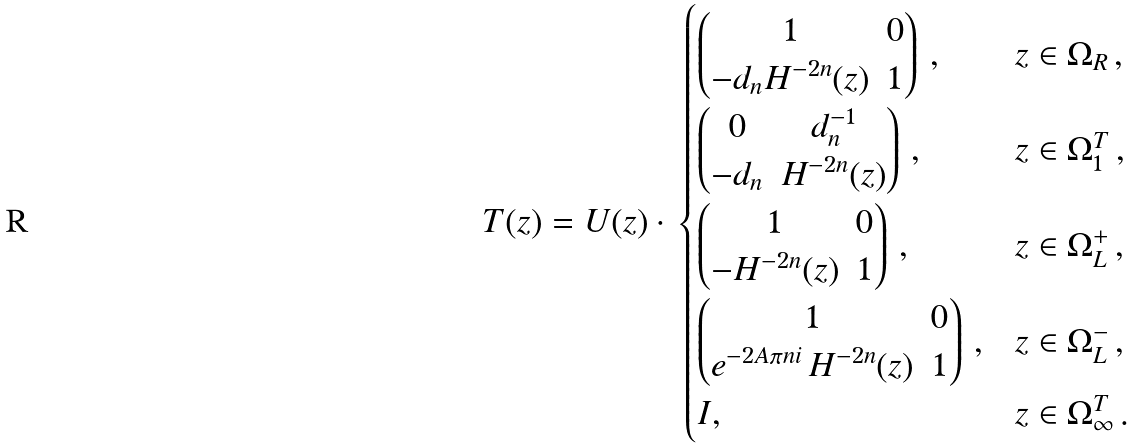<formula> <loc_0><loc_0><loc_500><loc_500>T ( z ) = U ( z ) \cdot \, \begin{cases} \begin{pmatrix} 1 & 0 \\ - d _ { n } H ^ { - 2 n } ( z ) & 1 \end{pmatrix} \, , & z \in \Omega _ { R } \, , \\ \begin{pmatrix} 0 & d _ { n } ^ { - 1 } \\ - d _ { n } & H ^ { - 2 n } ( z ) \end{pmatrix} \, , & z \in \Omega _ { 1 } ^ { T } \, , \\ \begin{pmatrix} 1 & 0 \\ - H ^ { - 2 n } ( z ) & 1 \end{pmatrix} \, , & z \in \Omega _ { L } ^ { + } \, , \\ \begin{pmatrix} 1 & 0 \\ e ^ { - 2 A \pi n i } \, H ^ { - 2 n } ( z ) & 1 \end{pmatrix} \, , & z \in \Omega _ { L } ^ { - } \, , \\ I , & z \in \Omega _ { \infty } ^ { T } \, . \end{cases}</formula> 